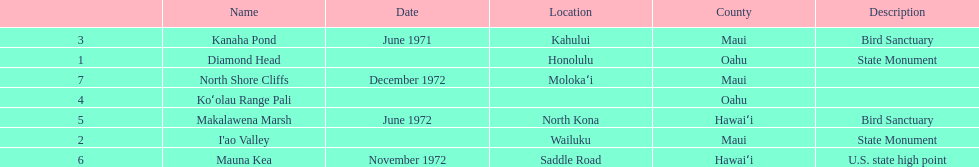Which national natural landmarks in hawaii are in oahu county? Diamond Head, Koʻolau Range Pali. Of these landmarks, which one is listed without a location? Koʻolau Range Pali. 